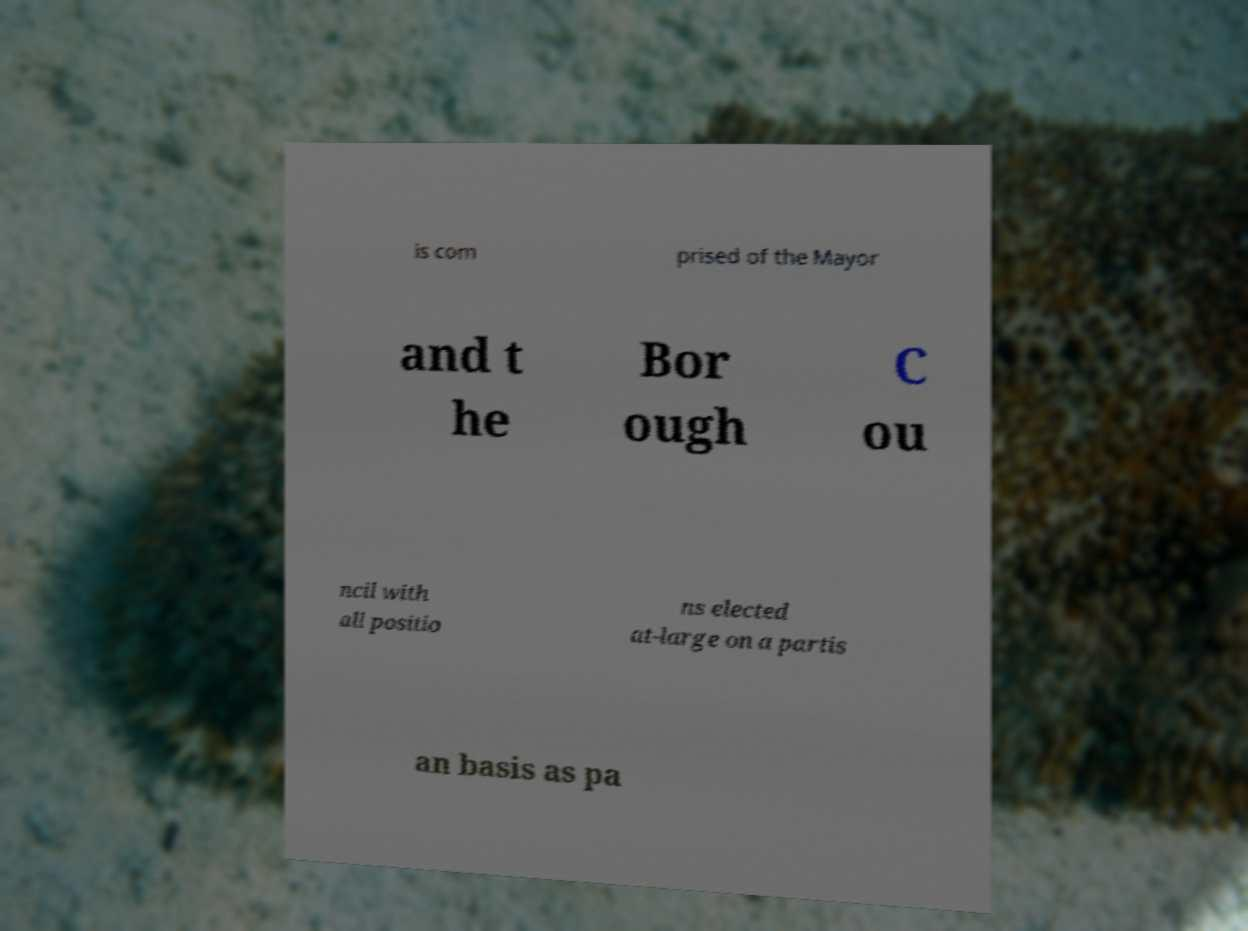For documentation purposes, I need the text within this image transcribed. Could you provide that? is com prised of the Mayor and t he Bor ough C ou ncil with all positio ns elected at-large on a partis an basis as pa 